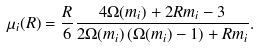<formula> <loc_0><loc_0><loc_500><loc_500>\mu _ { i } ( R ) = \frac { R } { 6 } \frac { 4 \Omega ( m _ { i } ) + 2 R m _ { i } - 3 } { 2 \Omega ( m _ { i } ) \left ( \Omega ( m _ { i } ) - 1 \right ) + R m _ { i } } .</formula> 